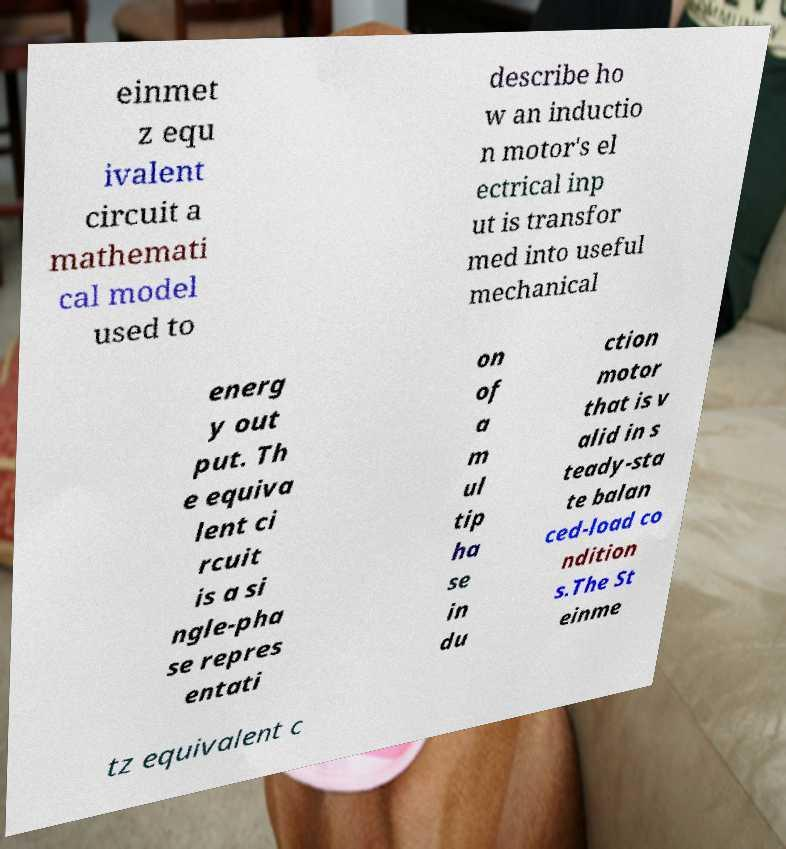There's text embedded in this image that I need extracted. Can you transcribe it verbatim? einmet z equ ivalent circuit a mathemati cal model used to describe ho w an inductio n motor's el ectrical inp ut is transfor med into useful mechanical energ y out put. Th e equiva lent ci rcuit is a si ngle-pha se repres entati on of a m ul tip ha se in du ction motor that is v alid in s teady-sta te balan ced-load co ndition s.The St einme tz equivalent c 